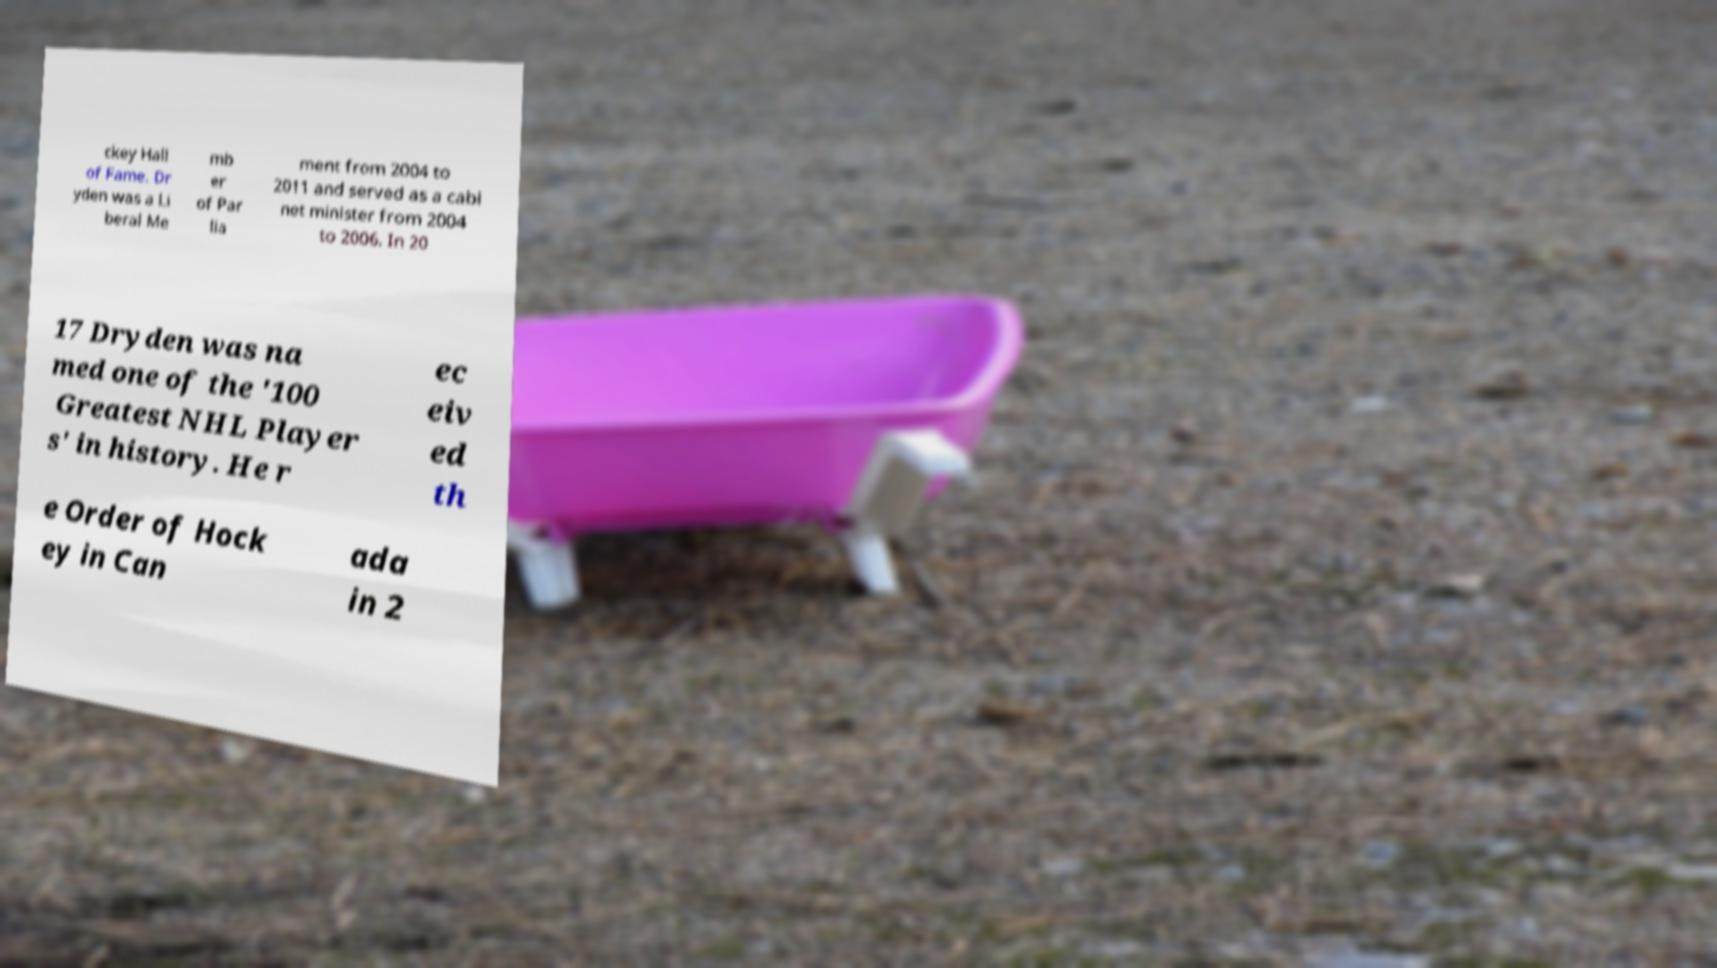Can you accurately transcribe the text from the provided image for me? ckey Hall of Fame. Dr yden was a Li beral Me mb er of Par lia ment from 2004 to 2011 and served as a cabi net minister from 2004 to 2006. In 20 17 Dryden was na med one of the '100 Greatest NHL Player s' in history. He r ec eiv ed th e Order of Hock ey in Can ada in 2 